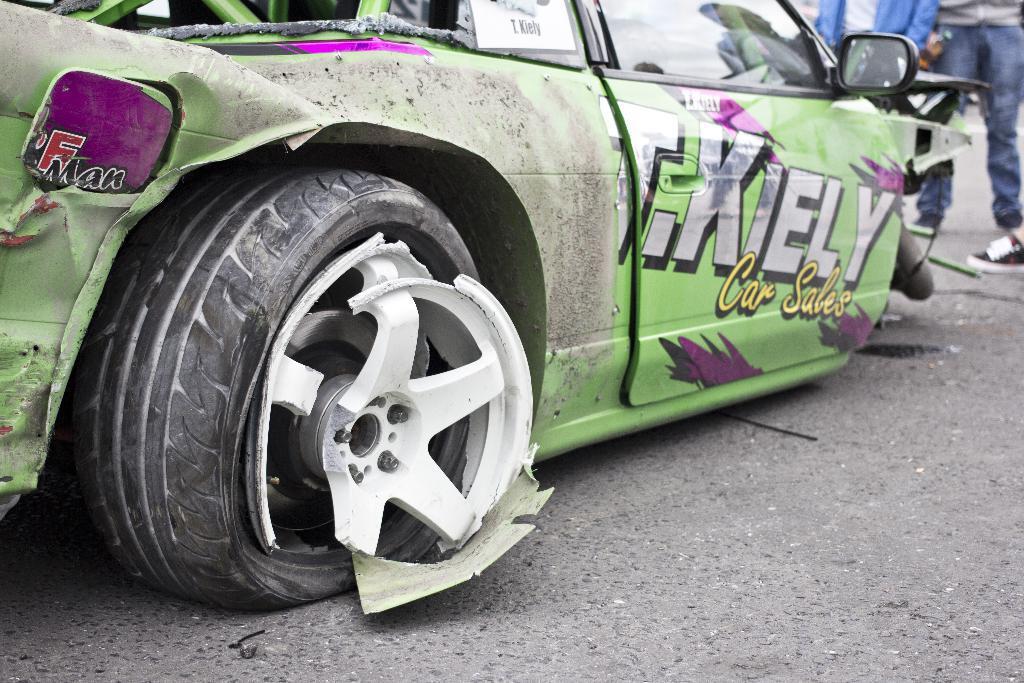Can you describe this image briefly? In this image there is a car on the road. Right side a person is standing on the road. Left side the rim of the tire is broken. 